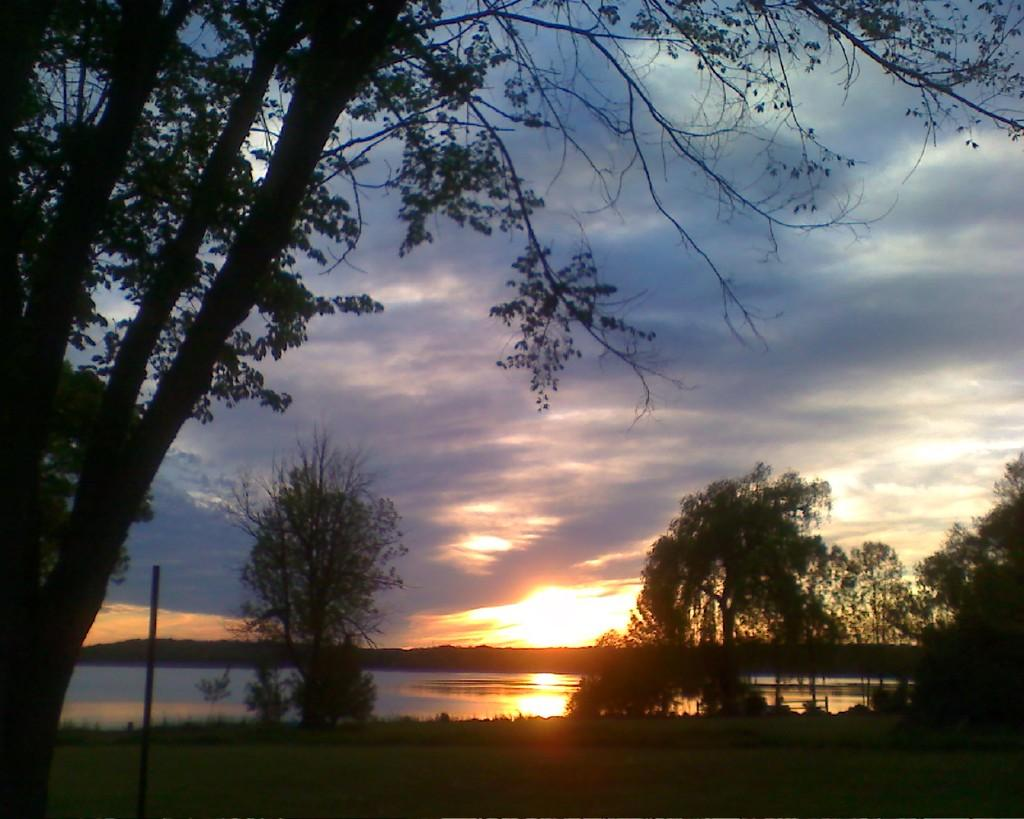What is the overall lighting condition of the image? The image is dark. What type of surface can be seen in the image? There is ground visible in the image. What structure is present in the image? There is a pole in the image. What type of vegetation is visible in the image? There are trees in the image. What natural element can be seen in the image? There is water visible in the image. What is visible in the background of the image? The sky and the sun are visible in the background of the image. What type of transport can be seen in the image? There is no transport visible in the image. What can be heard in the image? The image is a still picture, so no sounds or hearing can be experienced from it. 